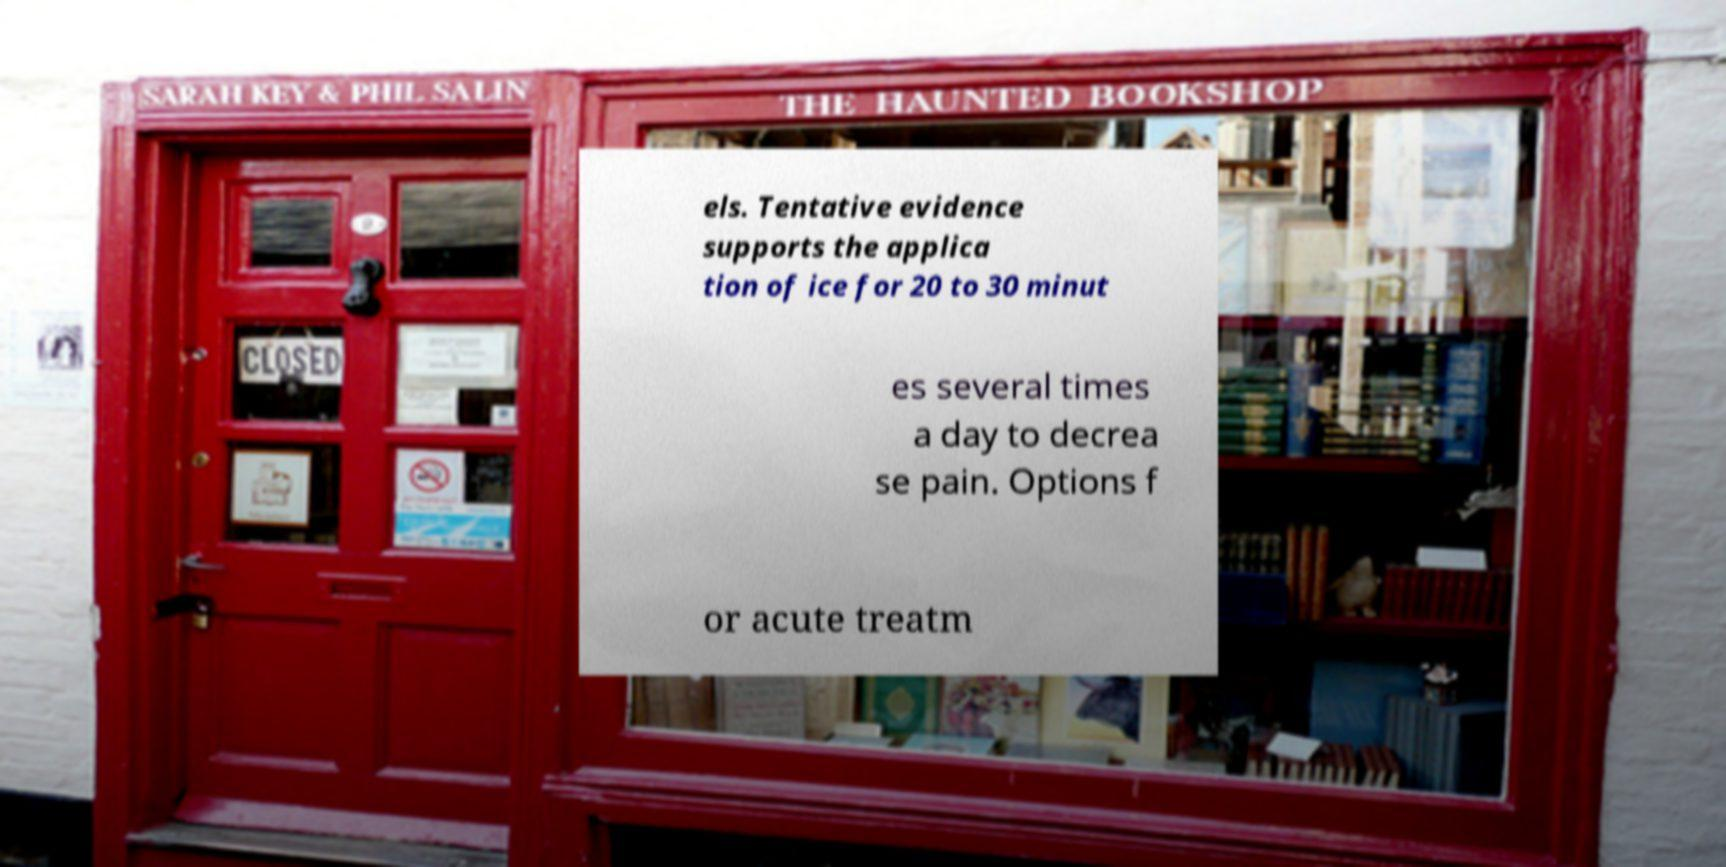For documentation purposes, I need the text within this image transcribed. Could you provide that? els. Tentative evidence supports the applica tion of ice for 20 to 30 minut es several times a day to decrea se pain. Options f or acute treatm 